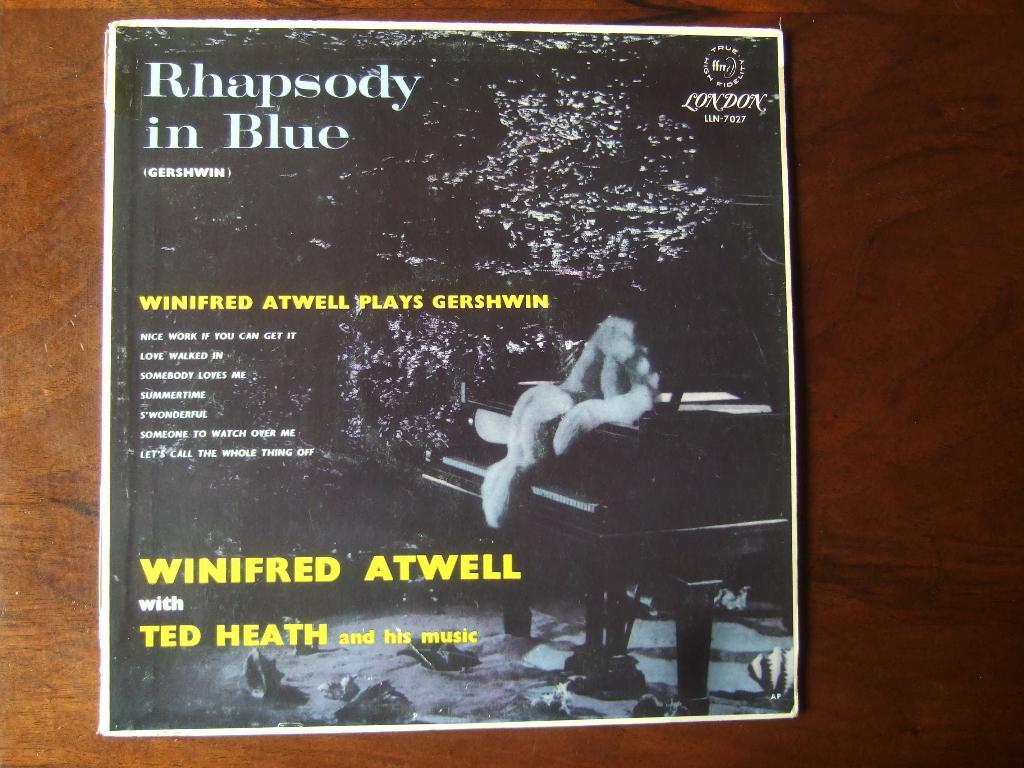Who are the artist of this album?
Your answer should be compact. Winifred atwell and ted heath. Whats the writings about?
Your answer should be compact. Rhapsody in blue. 